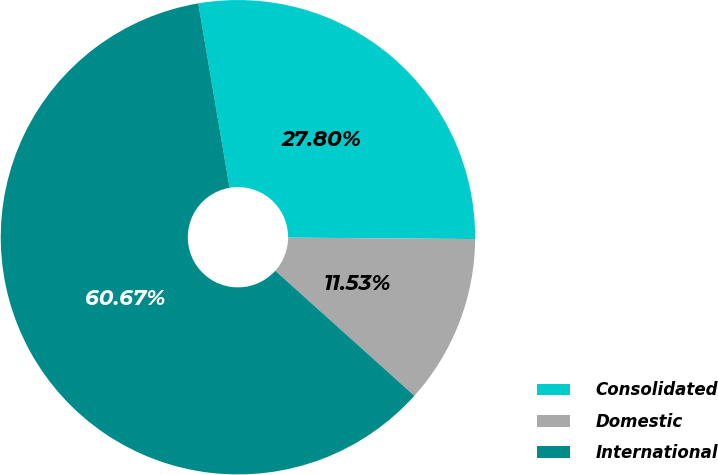Convert chart to OTSL. <chart><loc_0><loc_0><loc_500><loc_500><pie_chart><fcel>Consolidated<fcel>Domestic<fcel>International<nl><fcel>27.8%<fcel>11.53%<fcel>60.68%<nl></chart> 